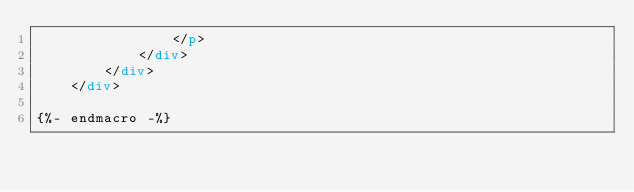<code> <loc_0><loc_0><loc_500><loc_500><_HTML_>                </p>
            </div>
        </div>
    </div>

{%- endmacro -%}
</code> 